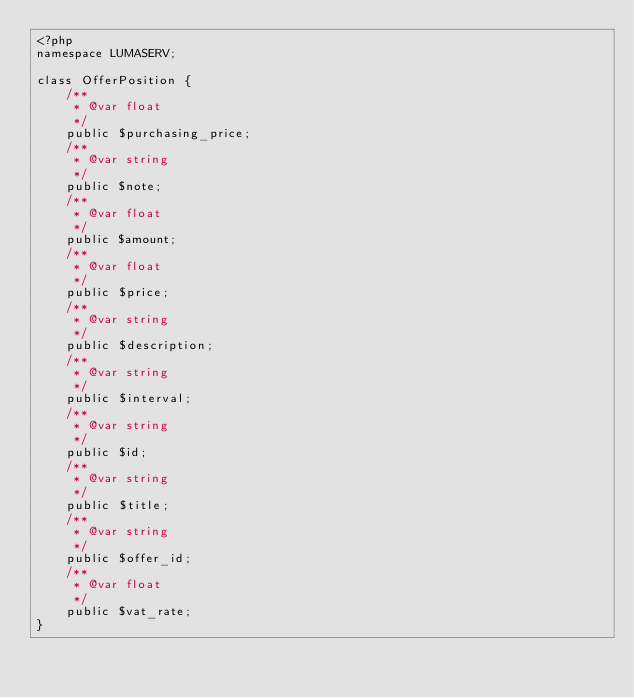Convert code to text. <code><loc_0><loc_0><loc_500><loc_500><_PHP_><?php
namespace LUMASERV;

class OfferPosition {
    /**
     * @var float
     */
    public $purchasing_price;
    /**
     * @var string
     */
    public $note;
    /**
     * @var float
     */
    public $amount;
    /**
     * @var float
     */
    public $price;
    /**
     * @var string
     */
    public $description;
    /**
     * @var string
     */
    public $interval;
    /**
     * @var string
     */
    public $id;
    /**
     * @var string
     */
    public $title;
    /**
     * @var string
     */
    public $offer_id;
    /**
     * @var float
     */
    public $vat_rate;
}

</code> 